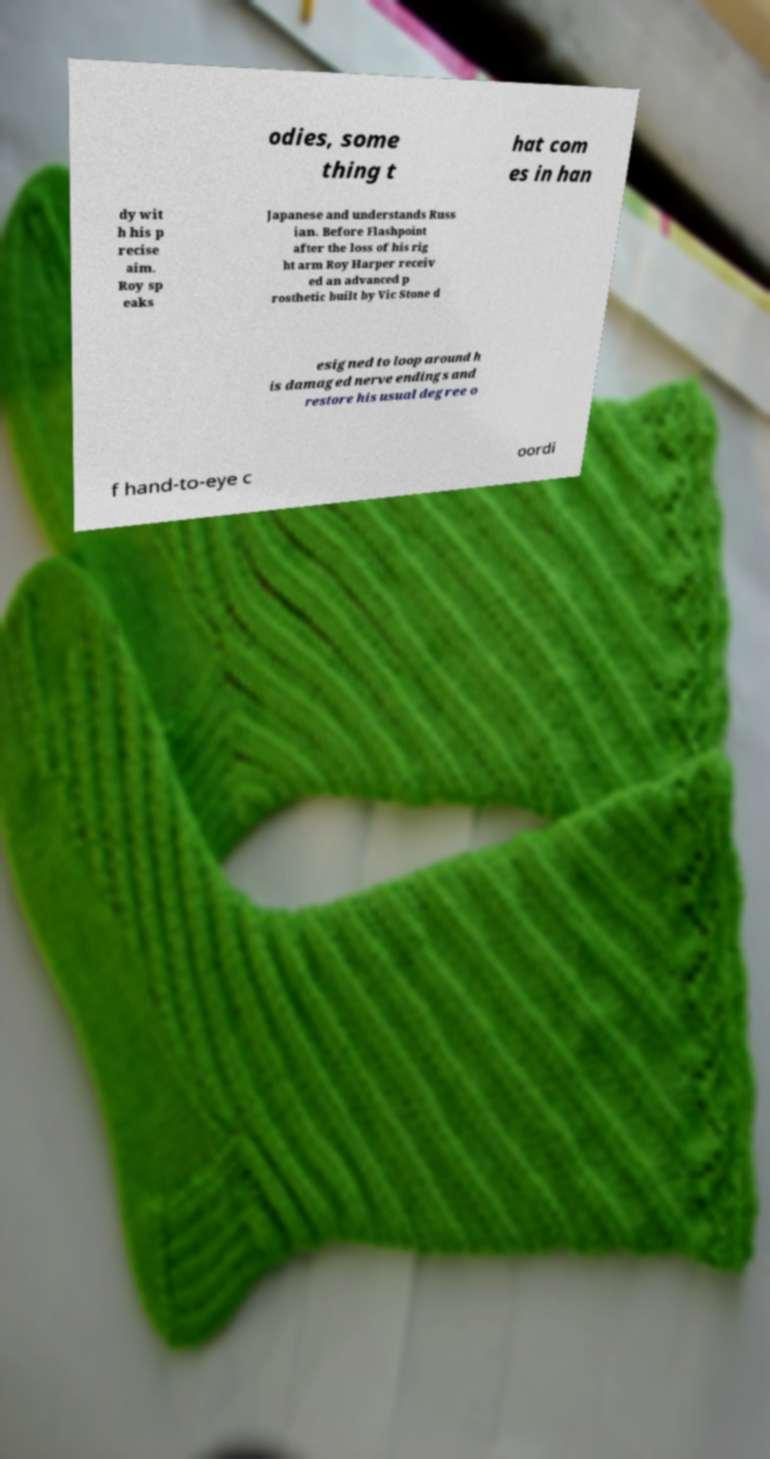Can you accurately transcribe the text from the provided image for me? odies, some thing t hat com es in han dy wit h his p recise aim. Roy sp eaks Japanese and understands Russ ian. Before Flashpoint after the loss of his rig ht arm Roy Harper receiv ed an advanced p rosthetic built by Vic Stone d esigned to loop around h is damaged nerve endings and restore his usual degree o f hand-to-eye c oordi 